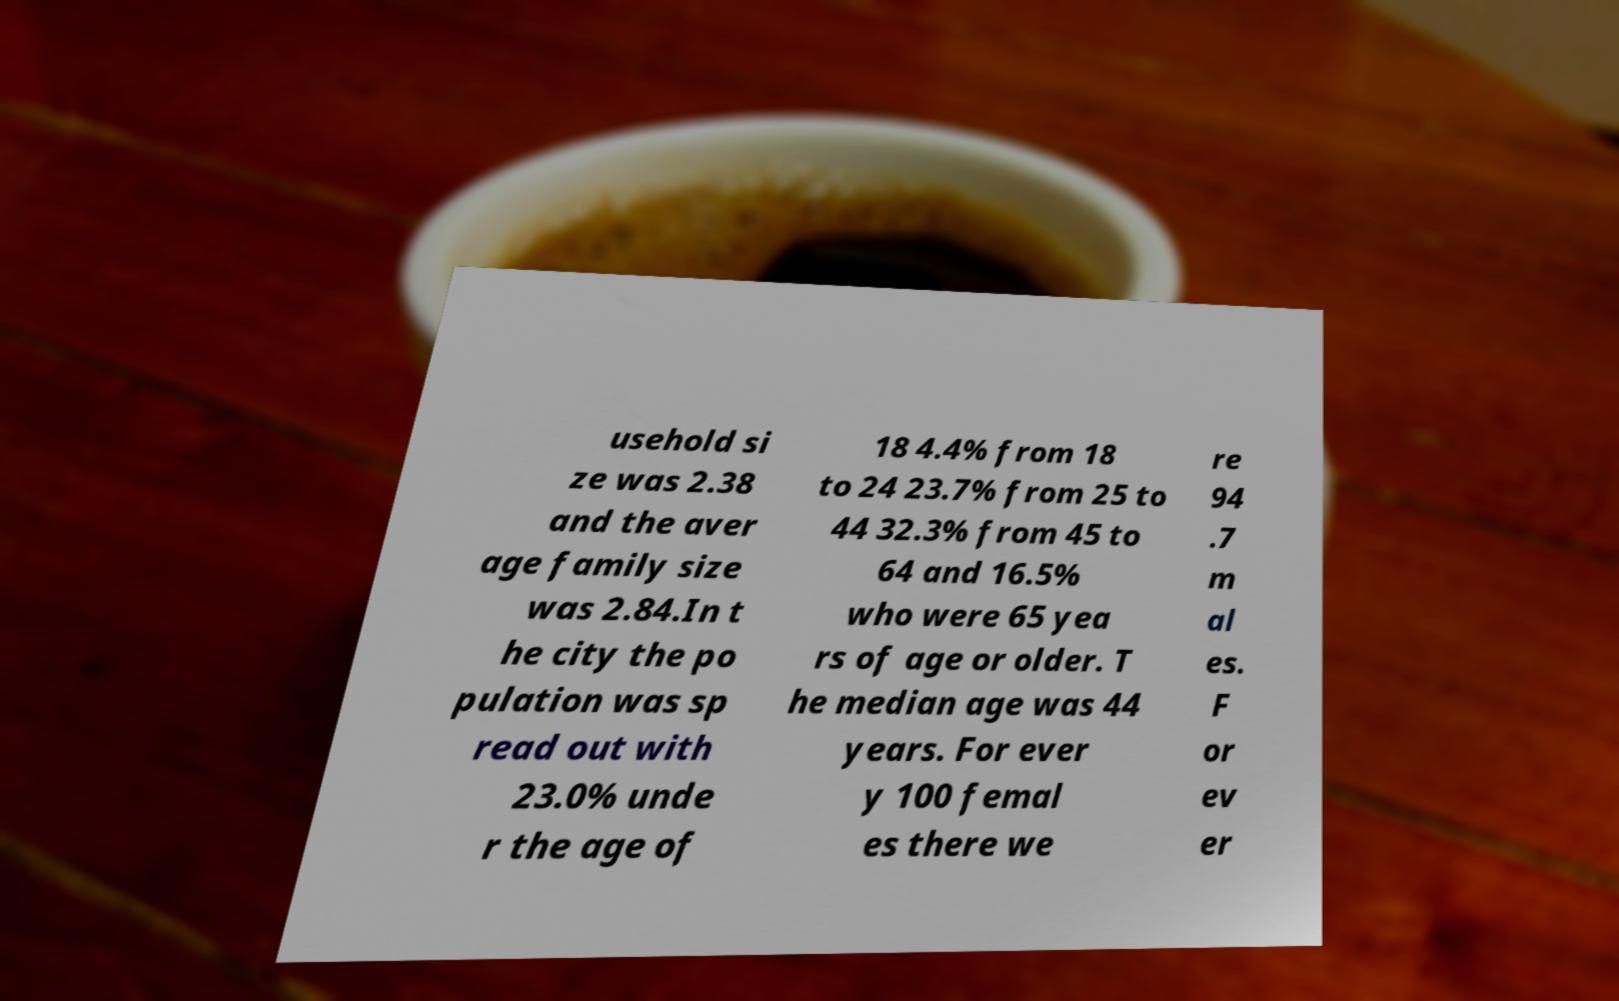Can you accurately transcribe the text from the provided image for me? usehold si ze was 2.38 and the aver age family size was 2.84.In t he city the po pulation was sp read out with 23.0% unde r the age of 18 4.4% from 18 to 24 23.7% from 25 to 44 32.3% from 45 to 64 and 16.5% who were 65 yea rs of age or older. T he median age was 44 years. For ever y 100 femal es there we re 94 .7 m al es. F or ev er 